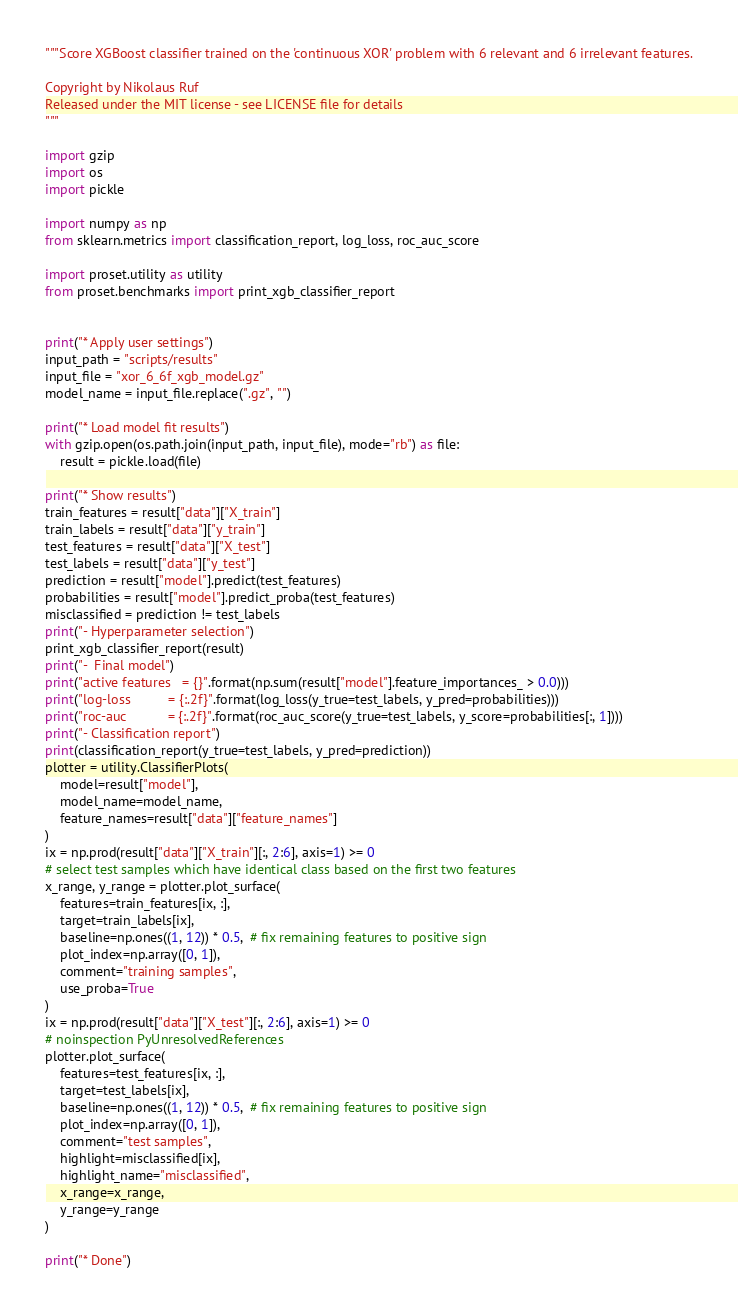Convert code to text. <code><loc_0><loc_0><loc_500><loc_500><_Python_>"""Score XGBoost classifier trained on the 'continuous XOR' problem with 6 relevant and 6 irrelevant features.

Copyright by Nikolaus Ruf
Released under the MIT license - see LICENSE file for details
"""

import gzip
import os
import pickle

import numpy as np
from sklearn.metrics import classification_report, log_loss, roc_auc_score

import proset.utility as utility
from proset.benchmarks import print_xgb_classifier_report


print("* Apply user settings")
input_path = "scripts/results"
input_file = "xor_6_6f_xgb_model.gz"
model_name = input_file.replace(".gz", "")

print("* Load model fit results")
with gzip.open(os.path.join(input_path, input_file), mode="rb") as file:
    result = pickle.load(file)

print("* Show results")
train_features = result["data"]["X_train"]
train_labels = result["data"]["y_train"]
test_features = result["data"]["X_test"]
test_labels = result["data"]["y_test"]
prediction = result["model"].predict(test_features)
probabilities = result["model"].predict_proba(test_features)
misclassified = prediction != test_labels
print("- Hyperparameter selection")
print_xgb_classifier_report(result)
print("-  Final model")
print("active features   = {}".format(np.sum(result["model"].feature_importances_ > 0.0)))
print("log-loss          = {:.2f}".format(log_loss(y_true=test_labels, y_pred=probabilities)))
print("roc-auc           = {:.2f}".format(roc_auc_score(y_true=test_labels, y_score=probabilities[:, 1])))
print("- Classification report")
print(classification_report(y_true=test_labels, y_pred=prediction))
plotter = utility.ClassifierPlots(
    model=result["model"],
    model_name=model_name,
    feature_names=result["data"]["feature_names"]
)
ix = np.prod(result["data"]["X_train"][:, 2:6], axis=1) >= 0
# select test samples which have identical class based on the first two features
x_range, y_range = plotter.plot_surface(
    features=train_features[ix, :],
    target=train_labels[ix],
    baseline=np.ones((1, 12)) * 0.5,  # fix remaining features to positive sign
    plot_index=np.array([0, 1]),
    comment="training samples",
    use_proba=True
)
ix = np.prod(result["data"]["X_test"][:, 2:6], axis=1) >= 0
# noinspection PyUnresolvedReferences
plotter.plot_surface(
    features=test_features[ix, :],
    target=test_labels[ix],
    baseline=np.ones((1, 12)) * 0.5,  # fix remaining features to positive sign
    plot_index=np.array([0, 1]),
    comment="test samples",
    highlight=misclassified[ix],
    highlight_name="misclassified",
    x_range=x_range,
    y_range=y_range
)

print("* Done")
</code> 